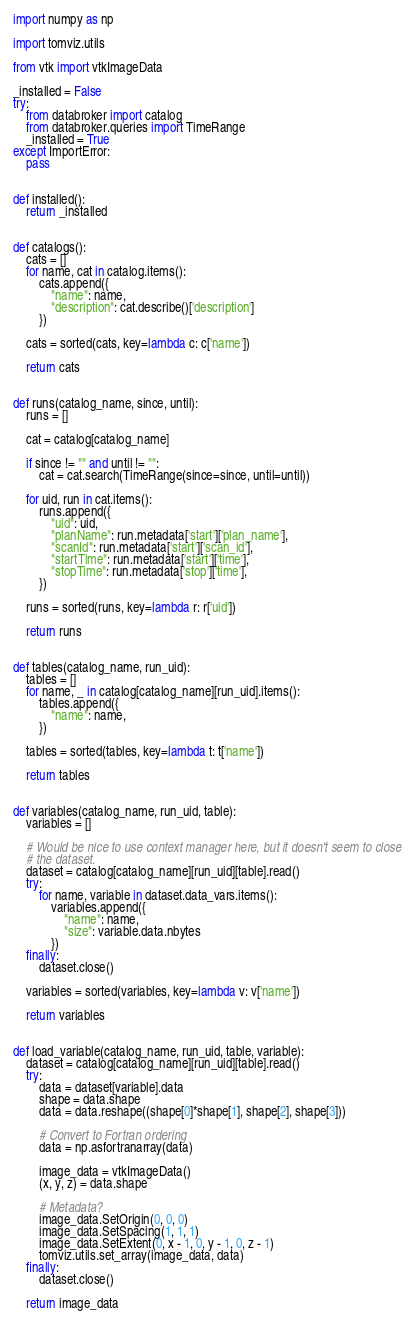<code> <loc_0><loc_0><loc_500><loc_500><_Python_>import numpy as np

import tomviz.utils

from vtk import vtkImageData

_installed = False
try:
    from databroker import catalog
    from databroker.queries import TimeRange
    _installed = True
except ImportError:
    pass


def installed():
    return _installed


def catalogs():
    cats = []
    for name, cat in catalog.items():
        cats.append({
            "name": name,
            "description": cat.describe()['description']
        })

    cats = sorted(cats, key=lambda c: c['name'])

    return cats


def runs(catalog_name, since, until):
    runs = []

    cat = catalog[catalog_name]

    if since != "" and until != "":
        cat = cat.search(TimeRange(since=since, until=until))

    for uid, run in cat.items():
        runs.append({
            "uid": uid,
            "planName": run.metadata['start']['plan_name'],
            "scanId": run.metadata['start']['scan_id'],
            "startTime": run.metadata['start']['time'],
            "stopTime": run.metadata['stop']['time'],
        })

    runs = sorted(runs, key=lambda r: r['uid'])

    return runs


def tables(catalog_name, run_uid):
    tables = []
    for name, _ in catalog[catalog_name][run_uid].items():
        tables.append({
            "name": name,
        })

    tables = sorted(tables, key=lambda t: t['name'])

    return tables


def variables(catalog_name, run_uid, table):
    variables = []

    # Would be nice to use context manager here, but it doesn't seem to close
    # the dataset.
    dataset = catalog[catalog_name][run_uid][table].read()
    try:
        for name, variable in dataset.data_vars.items():
            variables.append({
                "name": name,
                "size": variable.data.nbytes
            })
    finally:
        dataset.close()

    variables = sorted(variables, key=lambda v: v['name'])

    return variables


def load_variable(catalog_name, run_uid, table, variable):
    dataset = catalog[catalog_name][run_uid][table].read()
    try:
        data = dataset[variable].data
        shape = data.shape
        data = data.reshape((shape[0]*shape[1], shape[2], shape[3]))

        # Convert to Fortran ordering
        data = np.asfortranarray(data)

        image_data = vtkImageData()
        (x, y, z) = data.shape

        # Metadata?
        image_data.SetOrigin(0, 0, 0)
        image_data.SetSpacing(1, 1, 1)
        image_data.SetExtent(0, x - 1, 0, y - 1, 0, z - 1)
        tomviz.utils.set_array(image_data, data)
    finally:
        dataset.close()

    return image_data
</code> 